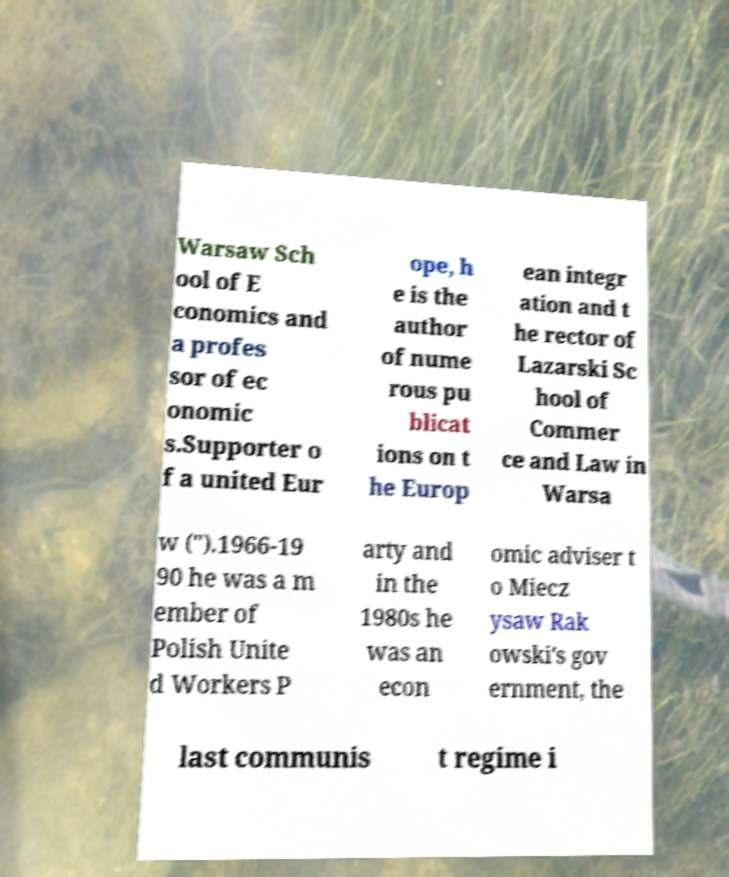Can you accurately transcribe the text from the provided image for me? Warsaw Sch ool of E conomics and a profes sor of ec onomic s.Supporter o f a united Eur ope, h e is the author of nume rous pu blicat ions on t he Europ ean integr ation and t he rector of Lazarski Sc hool of Commer ce and Law in Warsa w (").1966-19 90 he was a m ember of Polish Unite d Workers P arty and in the 1980s he was an econ omic adviser t o Miecz ysaw Rak owski's gov ernment, the last communis t regime i 